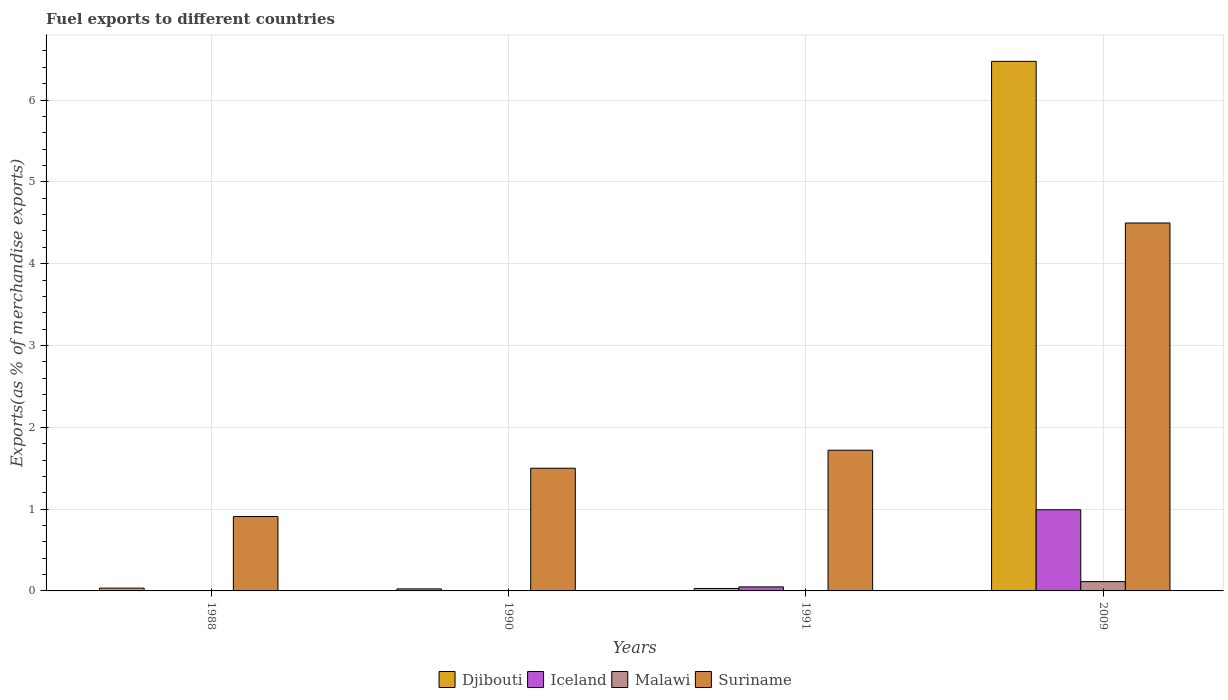How many different coloured bars are there?
Your answer should be very brief. 4. Are the number of bars on each tick of the X-axis equal?
Your answer should be very brief. Yes. How many bars are there on the 1st tick from the left?
Your response must be concise. 4. How many bars are there on the 1st tick from the right?
Ensure brevity in your answer.  4. In how many cases, is the number of bars for a given year not equal to the number of legend labels?
Offer a terse response. 0. What is the percentage of exports to different countries in Malawi in 1988?
Your answer should be very brief. 0. Across all years, what is the maximum percentage of exports to different countries in Iceland?
Your response must be concise. 0.99. Across all years, what is the minimum percentage of exports to different countries in Malawi?
Ensure brevity in your answer.  0. In which year was the percentage of exports to different countries in Suriname maximum?
Your response must be concise. 2009. In which year was the percentage of exports to different countries in Suriname minimum?
Your answer should be very brief. 1988. What is the total percentage of exports to different countries in Suriname in the graph?
Offer a terse response. 8.63. What is the difference between the percentage of exports to different countries in Djibouti in 1991 and that in 2009?
Your answer should be very brief. -6.44. What is the difference between the percentage of exports to different countries in Iceland in 2009 and the percentage of exports to different countries in Suriname in 1991?
Offer a very short reply. -0.73. What is the average percentage of exports to different countries in Malawi per year?
Your answer should be very brief. 0.03. In the year 1991, what is the difference between the percentage of exports to different countries in Malawi and percentage of exports to different countries in Iceland?
Give a very brief answer. -0.05. What is the ratio of the percentage of exports to different countries in Suriname in 1988 to that in 2009?
Your response must be concise. 0.2. Is the difference between the percentage of exports to different countries in Malawi in 1988 and 2009 greater than the difference between the percentage of exports to different countries in Iceland in 1988 and 2009?
Provide a short and direct response. Yes. What is the difference between the highest and the second highest percentage of exports to different countries in Djibouti?
Ensure brevity in your answer.  6.44. What is the difference between the highest and the lowest percentage of exports to different countries in Iceland?
Offer a terse response. 0.99. What does the 3rd bar from the left in 2009 represents?
Your answer should be compact. Malawi. What does the 4th bar from the right in 1990 represents?
Your response must be concise. Djibouti. How many bars are there?
Give a very brief answer. 16. How many years are there in the graph?
Your answer should be compact. 4. What is the difference between two consecutive major ticks on the Y-axis?
Offer a terse response. 1. Are the values on the major ticks of Y-axis written in scientific E-notation?
Offer a terse response. No. Does the graph contain any zero values?
Offer a very short reply. No. How many legend labels are there?
Offer a very short reply. 4. How are the legend labels stacked?
Provide a succinct answer. Horizontal. What is the title of the graph?
Your answer should be compact. Fuel exports to different countries. Does "Macedonia" appear as one of the legend labels in the graph?
Keep it short and to the point. No. What is the label or title of the Y-axis?
Give a very brief answer. Exports(as % of merchandise exports). What is the Exports(as % of merchandise exports) of Djibouti in 1988?
Offer a terse response. 0.03. What is the Exports(as % of merchandise exports) of Iceland in 1988?
Your response must be concise. 0. What is the Exports(as % of merchandise exports) of Malawi in 1988?
Your answer should be compact. 0. What is the Exports(as % of merchandise exports) in Suriname in 1988?
Keep it short and to the point. 0.91. What is the Exports(as % of merchandise exports) in Djibouti in 1990?
Offer a terse response. 0.02. What is the Exports(as % of merchandise exports) in Iceland in 1990?
Ensure brevity in your answer.  0. What is the Exports(as % of merchandise exports) of Malawi in 1990?
Offer a very short reply. 0. What is the Exports(as % of merchandise exports) of Suriname in 1990?
Make the answer very short. 1.5. What is the Exports(as % of merchandise exports) of Djibouti in 1991?
Provide a short and direct response. 0.03. What is the Exports(as % of merchandise exports) in Iceland in 1991?
Ensure brevity in your answer.  0.05. What is the Exports(as % of merchandise exports) of Malawi in 1991?
Your response must be concise. 0. What is the Exports(as % of merchandise exports) of Suriname in 1991?
Your answer should be very brief. 1.72. What is the Exports(as % of merchandise exports) of Djibouti in 2009?
Make the answer very short. 6.47. What is the Exports(as % of merchandise exports) of Iceland in 2009?
Provide a succinct answer. 0.99. What is the Exports(as % of merchandise exports) of Malawi in 2009?
Provide a succinct answer. 0.11. What is the Exports(as % of merchandise exports) in Suriname in 2009?
Provide a succinct answer. 4.5. Across all years, what is the maximum Exports(as % of merchandise exports) in Djibouti?
Make the answer very short. 6.47. Across all years, what is the maximum Exports(as % of merchandise exports) of Iceland?
Offer a very short reply. 0.99. Across all years, what is the maximum Exports(as % of merchandise exports) of Malawi?
Make the answer very short. 0.11. Across all years, what is the maximum Exports(as % of merchandise exports) of Suriname?
Make the answer very short. 4.5. Across all years, what is the minimum Exports(as % of merchandise exports) in Djibouti?
Keep it short and to the point. 0.02. Across all years, what is the minimum Exports(as % of merchandise exports) of Iceland?
Offer a terse response. 0. Across all years, what is the minimum Exports(as % of merchandise exports) of Malawi?
Your answer should be compact. 0. Across all years, what is the minimum Exports(as % of merchandise exports) of Suriname?
Make the answer very short. 0.91. What is the total Exports(as % of merchandise exports) in Djibouti in the graph?
Provide a short and direct response. 6.56. What is the total Exports(as % of merchandise exports) in Iceland in the graph?
Offer a terse response. 1.04. What is the total Exports(as % of merchandise exports) of Malawi in the graph?
Make the answer very short. 0.12. What is the total Exports(as % of merchandise exports) in Suriname in the graph?
Your response must be concise. 8.63. What is the difference between the Exports(as % of merchandise exports) in Djibouti in 1988 and that in 1990?
Make the answer very short. 0.01. What is the difference between the Exports(as % of merchandise exports) of Iceland in 1988 and that in 1990?
Provide a succinct answer. 0. What is the difference between the Exports(as % of merchandise exports) of Malawi in 1988 and that in 1990?
Ensure brevity in your answer.  -0. What is the difference between the Exports(as % of merchandise exports) in Suriname in 1988 and that in 1990?
Your answer should be very brief. -0.59. What is the difference between the Exports(as % of merchandise exports) in Djibouti in 1988 and that in 1991?
Offer a very short reply. 0. What is the difference between the Exports(as % of merchandise exports) in Iceland in 1988 and that in 1991?
Offer a very short reply. -0.05. What is the difference between the Exports(as % of merchandise exports) in Malawi in 1988 and that in 1991?
Provide a short and direct response. -0. What is the difference between the Exports(as % of merchandise exports) of Suriname in 1988 and that in 1991?
Your answer should be very brief. -0.81. What is the difference between the Exports(as % of merchandise exports) in Djibouti in 1988 and that in 2009?
Make the answer very short. -6.44. What is the difference between the Exports(as % of merchandise exports) in Iceland in 1988 and that in 2009?
Give a very brief answer. -0.99. What is the difference between the Exports(as % of merchandise exports) in Malawi in 1988 and that in 2009?
Offer a terse response. -0.11. What is the difference between the Exports(as % of merchandise exports) in Suriname in 1988 and that in 2009?
Keep it short and to the point. -3.59. What is the difference between the Exports(as % of merchandise exports) of Djibouti in 1990 and that in 1991?
Keep it short and to the point. -0.01. What is the difference between the Exports(as % of merchandise exports) in Iceland in 1990 and that in 1991?
Make the answer very short. -0.05. What is the difference between the Exports(as % of merchandise exports) of Malawi in 1990 and that in 1991?
Your answer should be very brief. 0. What is the difference between the Exports(as % of merchandise exports) in Suriname in 1990 and that in 1991?
Your response must be concise. -0.22. What is the difference between the Exports(as % of merchandise exports) of Djibouti in 1990 and that in 2009?
Give a very brief answer. -6.45. What is the difference between the Exports(as % of merchandise exports) in Iceland in 1990 and that in 2009?
Give a very brief answer. -0.99. What is the difference between the Exports(as % of merchandise exports) of Malawi in 1990 and that in 2009?
Your answer should be very brief. -0.11. What is the difference between the Exports(as % of merchandise exports) in Suriname in 1990 and that in 2009?
Keep it short and to the point. -3. What is the difference between the Exports(as % of merchandise exports) in Djibouti in 1991 and that in 2009?
Give a very brief answer. -6.44. What is the difference between the Exports(as % of merchandise exports) of Iceland in 1991 and that in 2009?
Offer a terse response. -0.94. What is the difference between the Exports(as % of merchandise exports) of Malawi in 1991 and that in 2009?
Your response must be concise. -0.11. What is the difference between the Exports(as % of merchandise exports) in Suriname in 1991 and that in 2009?
Offer a very short reply. -2.78. What is the difference between the Exports(as % of merchandise exports) of Djibouti in 1988 and the Exports(as % of merchandise exports) of Iceland in 1990?
Make the answer very short. 0.03. What is the difference between the Exports(as % of merchandise exports) in Djibouti in 1988 and the Exports(as % of merchandise exports) in Malawi in 1990?
Your response must be concise. 0.03. What is the difference between the Exports(as % of merchandise exports) of Djibouti in 1988 and the Exports(as % of merchandise exports) of Suriname in 1990?
Keep it short and to the point. -1.47. What is the difference between the Exports(as % of merchandise exports) of Iceland in 1988 and the Exports(as % of merchandise exports) of Malawi in 1990?
Keep it short and to the point. -0. What is the difference between the Exports(as % of merchandise exports) of Iceland in 1988 and the Exports(as % of merchandise exports) of Suriname in 1990?
Provide a short and direct response. -1.5. What is the difference between the Exports(as % of merchandise exports) in Malawi in 1988 and the Exports(as % of merchandise exports) in Suriname in 1990?
Your response must be concise. -1.5. What is the difference between the Exports(as % of merchandise exports) in Djibouti in 1988 and the Exports(as % of merchandise exports) in Iceland in 1991?
Provide a succinct answer. -0.01. What is the difference between the Exports(as % of merchandise exports) of Djibouti in 1988 and the Exports(as % of merchandise exports) of Malawi in 1991?
Offer a very short reply. 0.03. What is the difference between the Exports(as % of merchandise exports) of Djibouti in 1988 and the Exports(as % of merchandise exports) of Suriname in 1991?
Ensure brevity in your answer.  -1.69. What is the difference between the Exports(as % of merchandise exports) in Iceland in 1988 and the Exports(as % of merchandise exports) in Malawi in 1991?
Ensure brevity in your answer.  -0. What is the difference between the Exports(as % of merchandise exports) in Iceland in 1988 and the Exports(as % of merchandise exports) in Suriname in 1991?
Ensure brevity in your answer.  -1.72. What is the difference between the Exports(as % of merchandise exports) of Malawi in 1988 and the Exports(as % of merchandise exports) of Suriname in 1991?
Provide a succinct answer. -1.72. What is the difference between the Exports(as % of merchandise exports) of Djibouti in 1988 and the Exports(as % of merchandise exports) of Iceland in 2009?
Offer a terse response. -0.96. What is the difference between the Exports(as % of merchandise exports) of Djibouti in 1988 and the Exports(as % of merchandise exports) of Malawi in 2009?
Provide a short and direct response. -0.08. What is the difference between the Exports(as % of merchandise exports) in Djibouti in 1988 and the Exports(as % of merchandise exports) in Suriname in 2009?
Provide a short and direct response. -4.46. What is the difference between the Exports(as % of merchandise exports) in Iceland in 1988 and the Exports(as % of merchandise exports) in Malawi in 2009?
Give a very brief answer. -0.11. What is the difference between the Exports(as % of merchandise exports) of Iceland in 1988 and the Exports(as % of merchandise exports) of Suriname in 2009?
Offer a terse response. -4.5. What is the difference between the Exports(as % of merchandise exports) in Malawi in 1988 and the Exports(as % of merchandise exports) in Suriname in 2009?
Your answer should be compact. -4.5. What is the difference between the Exports(as % of merchandise exports) in Djibouti in 1990 and the Exports(as % of merchandise exports) in Iceland in 1991?
Offer a very short reply. -0.02. What is the difference between the Exports(as % of merchandise exports) of Djibouti in 1990 and the Exports(as % of merchandise exports) of Malawi in 1991?
Give a very brief answer. 0.02. What is the difference between the Exports(as % of merchandise exports) of Djibouti in 1990 and the Exports(as % of merchandise exports) of Suriname in 1991?
Ensure brevity in your answer.  -1.7. What is the difference between the Exports(as % of merchandise exports) of Iceland in 1990 and the Exports(as % of merchandise exports) of Malawi in 1991?
Keep it short and to the point. -0. What is the difference between the Exports(as % of merchandise exports) of Iceland in 1990 and the Exports(as % of merchandise exports) of Suriname in 1991?
Your answer should be compact. -1.72. What is the difference between the Exports(as % of merchandise exports) in Malawi in 1990 and the Exports(as % of merchandise exports) in Suriname in 1991?
Provide a succinct answer. -1.72. What is the difference between the Exports(as % of merchandise exports) of Djibouti in 1990 and the Exports(as % of merchandise exports) of Iceland in 2009?
Make the answer very short. -0.97. What is the difference between the Exports(as % of merchandise exports) in Djibouti in 1990 and the Exports(as % of merchandise exports) in Malawi in 2009?
Your response must be concise. -0.09. What is the difference between the Exports(as % of merchandise exports) of Djibouti in 1990 and the Exports(as % of merchandise exports) of Suriname in 2009?
Your answer should be compact. -4.47. What is the difference between the Exports(as % of merchandise exports) of Iceland in 1990 and the Exports(as % of merchandise exports) of Malawi in 2009?
Your answer should be very brief. -0.11. What is the difference between the Exports(as % of merchandise exports) of Iceland in 1990 and the Exports(as % of merchandise exports) of Suriname in 2009?
Offer a very short reply. -4.5. What is the difference between the Exports(as % of merchandise exports) of Malawi in 1990 and the Exports(as % of merchandise exports) of Suriname in 2009?
Provide a short and direct response. -4.49. What is the difference between the Exports(as % of merchandise exports) of Djibouti in 1991 and the Exports(as % of merchandise exports) of Iceland in 2009?
Your answer should be very brief. -0.96. What is the difference between the Exports(as % of merchandise exports) in Djibouti in 1991 and the Exports(as % of merchandise exports) in Malawi in 2009?
Offer a terse response. -0.08. What is the difference between the Exports(as % of merchandise exports) of Djibouti in 1991 and the Exports(as % of merchandise exports) of Suriname in 2009?
Make the answer very short. -4.47. What is the difference between the Exports(as % of merchandise exports) in Iceland in 1991 and the Exports(as % of merchandise exports) in Malawi in 2009?
Your answer should be compact. -0.06. What is the difference between the Exports(as % of merchandise exports) of Iceland in 1991 and the Exports(as % of merchandise exports) of Suriname in 2009?
Provide a succinct answer. -4.45. What is the difference between the Exports(as % of merchandise exports) in Malawi in 1991 and the Exports(as % of merchandise exports) in Suriname in 2009?
Your answer should be compact. -4.49. What is the average Exports(as % of merchandise exports) in Djibouti per year?
Provide a short and direct response. 1.64. What is the average Exports(as % of merchandise exports) in Iceland per year?
Provide a short and direct response. 0.26. What is the average Exports(as % of merchandise exports) in Malawi per year?
Offer a very short reply. 0.03. What is the average Exports(as % of merchandise exports) in Suriname per year?
Ensure brevity in your answer.  2.16. In the year 1988, what is the difference between the Exports(as % of merchandise exports) of Djibouti and Exports(as % of merchandise exports) of Iceland?
Provide a succinct answer. 0.03. In the year 1988, what is the difference between the Exports(as % of merchandise exports) of Djibouti and Exports(as % of merchandise exports) of Suriname?
Offer a terse response. -0.88. In the year 1988, what is the difference between the Exports(as % of merchandise exports) in Iceland and Exports(as % of merchandise exports) in Malawi?
Your answer should be very brief. 0. In the year 1988, what is the difference between the Exports(as % of merchandise exports) in Iceland and Exports(as % of merchandise exports) in Suriname?
Keep it short and to the point. -0.91. In the year 1988, what is the difference between the Exports(as % of merchandise exports) of Malawi and Exports(as % of merchandise exports) of Suriname?
Offer a terse response. -0.91. In the year 1990, what is the difference between the Exports(as % of merchandise exports) in Djibouti and Exports(as % of merchandise exports) in Iceland?
Your response must be concise. 0.02. In the year 1990, what is the difference between the Exports(as % of merchandise exports) in Djibouti and Exports(as % of merchandise exports) in Malawi?
Provide a succinct answer. 0.02. In the year 1990, what is the difference between the Exports(as % of merchandise exports) in Djibouti and Exports(as % of merchandise exports) in Suriname?
Your answer should be very brief. -1.48. In the year 1990, what is the difference between the Exports(as % of merchandise exports) of Iceland and Exports(as % of merchandise exports) of Malawi?
Your answer should be compact. -0. In the year 1990, what is the difference between the Exports(as % of merchandise exports) of Iceland and Exports(as % of merchandise exports) of Suriname?
Offer a very short reply. -1.5. In the year 1990, what is the difference between the Exports(as % of merchandise exports) in Malawi and Exports(as % of merchandise exports) in Suriname?
Your answer should be very brief. -1.5. In the year 1991, what is the difference between the Exports(as % of merchandise exports) in Djibouti and Exports(as % of merchandise exports) in Iceland?
Offer a terse response. -0.02. In the year 1991, what is the difference between the Exports(as % of merchandise exports) of Djibouti and Exports(as % of merchandise exports) of Malawi?
Keep it short and to the point. 0.03. In the year 1991, what is the difference between the Exports(as % of merchandise exports) in Djibouti and Exports(as % of merchandise exports) in Suriname?
Your answer should be compact. -1.69. In the year 1991, what is the difference between the Exports(as % of merchandise exports) of Iceland and Exports(as % of merchandise exports) of Malawi?
Your answer should be compact. 0.05. In the year 1991, what is the difference between the Exports(as % of merchandise exports) in Iceland and Exports(as % of merchandise exports) in Suriname?
Your answer should be very brief. -1.67. In the year 1991, what is the difference between the Exports(as % of merchandise exports) in Malawi and Exports(as % of merchandise exports) in Suriname?
Offer a very short reply. -1.72. In the year 2009, what is the difference between the Exports(as % of merchandise exports) in Djibouti and Exports(as % of merchandise exports) in Iceland?
Ensure brevity in your answer.  5.48. In the year 2009, what is the difference between the Exports(as % of merchandise exports) of Djibouti and Exports(as % of merchandise exports) of Malawi?
Your response must be concise. 6.36. In the year 2009, what is the difference between the Exports(as % of merchandise exports) in Djibouti and Exports(as % of merchandise exports) in Suriname?
Make the answer very short. 1.98. In the year 2009, what is the difference between the Exports(as % of merchandise exports) of Iceland and Exports(as % of merchandise exports) of Malawi?
Your answer should be compact. 0.88. In the year 2009, what is the difference between the Exports(as % of merchandise exports) of Iceland and Exports(as % of merchandise exports) of Suriname?
Keep it short and to the point. -3.51. In the year 2009, what is the difference between the Exports(as % of merchandise exports) of Malawi and Exports(as % of merchandise exports) of Suriname?
Make the answer very short. -4.38. What is the ratio of the Exports(as % of merchandise exports) in Djibouti in 1988 to that in 1990?
Your response must be concise. 1.38. What is the ratio of the Exports(as % of merchandise exports) in Iceland in 1988 to that in 1990?
Give a very brief answer. 1.82. What is the ratio of the Exports(as % of merchandise exports) in Malawi in 1988 to that in 1990?
Offer a very short reply. 0.34. What is the ratio of the Exports(as % of merchandise exports) in Suriname in 1988 to that in 1990?
Offer a very short reply. 0.61. What is the ratio of the Exports(as % of merchandise exports) of Djibouti in 1988 to that in 1991?
Make the answer very short. 1.14. What is the ratio of the Exports(as % of merchandise exports) of Iceland in 1988 to that in 1991?
Offer a very short reply. 0.04. What is the ratio of the Exports(as % of merchandise exports) of Malawi in 1988 to that in 1991?
Ensure brevity in your answer.  0.36. What is the ratio of the Exports(as % of merchandise exports) of Suriname in 1988 to that in 1991?
Your response must be concise. 0.53. What is the ratio of the Exports(as % of merchandise exports) of Djibouti in 1988 to that in 2009?
Make the answer very short. 0.01. What is the ratio of the Exports(as % of merchandise exports) in Iceland in 1988 to that in 2009?
Your answer should be very brief. 0. What is the ratio of the Exports(as % of merchandise exports) of Malawi in 1988 to that in 2009?
Offer a terse response. 0.01. What is the ratio of the Exports(as % of merchandise exports) of Suriname in 1988 to that in 2009?
Offer a terse response. 0.2. What is the ratio of the Exports(as % of merchandise exports) in Djibouti in 1990 to that in 1991?
Provide a short and direct response. 0.82. What is the ratio of the Exports(as % of merchandise exports) in Iceland in 1990 to that in 1991?
Offer a terse response. 0.02. What is the ratio of the Exports(as % of merchandise exports) in Malawi in 1990 to that in 1991?
Your answer should be compact. 1.05. What is the ratio of the Exports(as % of merchandise exports) in Suriname in 1990 to that in 1991?
Your answer should be compact. 0.87. What is the ratio of the Exports(as % of merchandise exports) in Djibouti in 1990 to that in 2009?
Offer a very short reply. 0. What is the ratio of the Exports(as % of merchandise exports) of Iceland in 1990 to that in 2009?
Provide a succinct answer. 0. What is the ratio of the Exports(as % of merchandise exports) of Malawi in 1990 to that in 2009?
Ensure brevity in your answer.  0.02. What is the ratio of the Exports(as % of merchandise exports) in Suriname in 1990 to that in 2009?
Your answer should be compact. 0.33. What is the ratio of the Exports(as % of merchandise exports) of Djibouti in 1991 to that in 2009?
Ensure brevity in your answer.  0. What is the ratio of the Exports(as % of merchandise exports) of Iceland in 1991 to that in 2009?
Your response must be concise. 0.05. What is the ratio of the Exports(as % of merchandise exports) in Malawi in 1991 to that in 2009?
Offer a very short reply. 0.02. What is the ratio of the Exports(as % of merchandise exports) of Suriname in 1991 to that in 2009?
Make the answer very short. 0.38. What is the difference between the highest and the second highest Exports(as % of merchandise exports) of Djibouti?
Your answer should be compact. 6.44. What is the difference between the highest and the second highest Exports(as % of merchandise exports) of Iceland?
Your response must be concise. 0.94. What is the difference between the highest and the second highest Exports(as % of merchandise exports) of Suriname?
Offer a very short reply. 2.78. What is the difference between the highest and the lowest Exports(as % of merchandise exports) of Djibouti?
Offer a terse response. 6.45. What is the difference between the highest and the lowest Exports(as % of merchandise exports) of Iceland?
Your answer should be very brief. 0.99. What is the difference between the highest and the lowest Exports(as % of merchandise exports) of Malawi?
Give a very brief answer. 0.11. What is the difference between the highest and the lowest Exports(as % of merchandise exports) in Suriname?
Offer a very short reply. 3.59. 